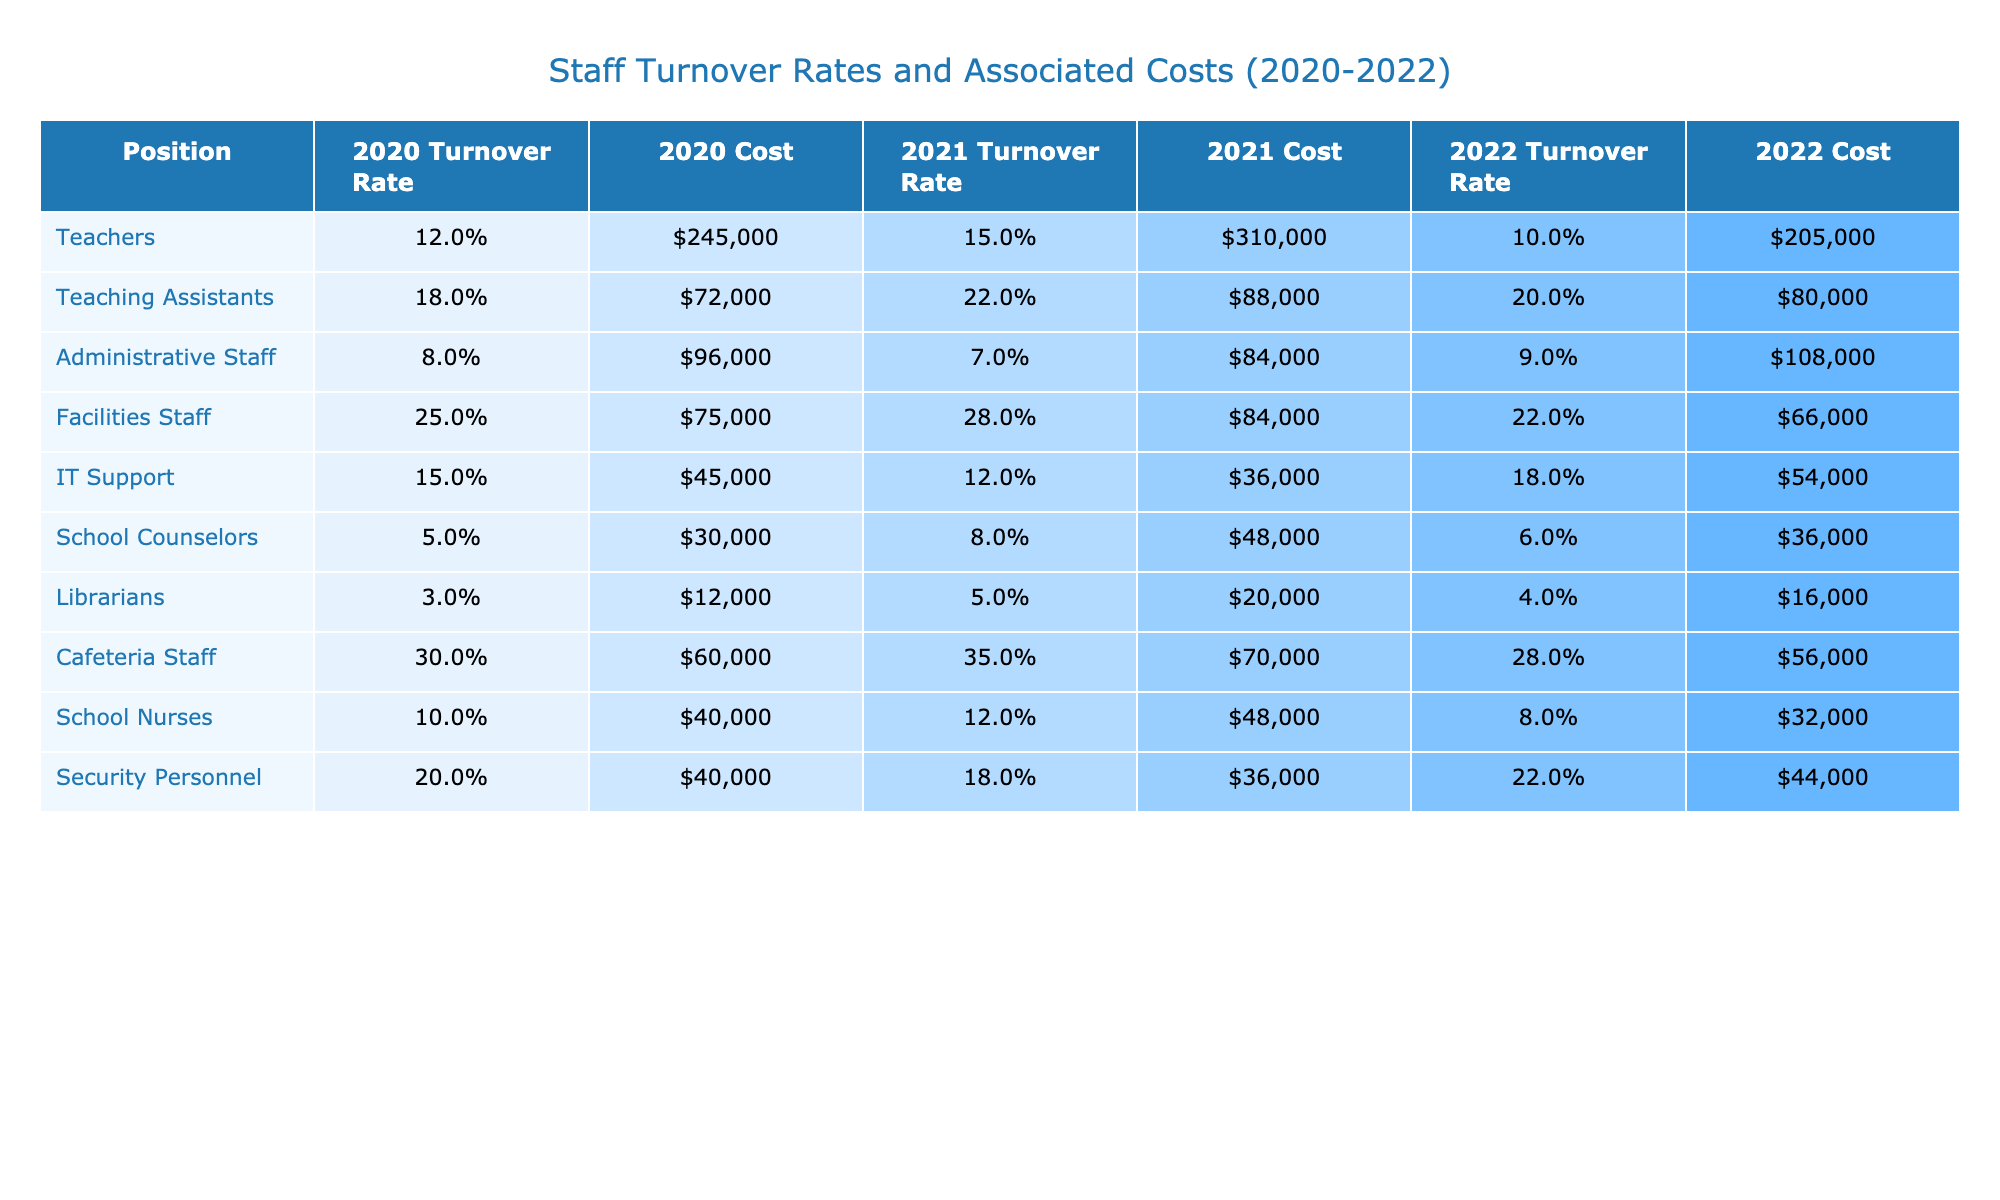What was the turnover rate for Teachers in 2021? The table shows the turnover rate for Teachers in 2021 is listed under the column for that year. Upon checking, it indicates that the rate is 15%.
Answer: 15% Which position had the highest turnover rate in 2020? By examining the turnover rates for each position in 2020, it is clear that Cafeteria Staff has the highest turnover rate at 30%.
Answer: Cafeteria Staff What was the total cost associated with turnover for Administrative Staff across the three years? The costs for Administrative Staff in each year are $96,000, $84,000, and $108,000. Adding these amounts gives a total of $288,000.
Answer: $288,000 Did the turnover cost for School Counselors increase from 2020 to 2021? The cost for School Counselors in 2020 was $30,000 and increased to $48,000 in 2021. Thus, the cost did increase.
Answer: Yes What is the average turnover rate for Teaching Assistants over the 3 years? The turnover rates for Teaching Assistants are 18%, 22%, and 20%. To find the average, sum these percentages (18 + 22 + 20 = 60) and divide by 3, resulting in an average of 20%.
Answer: 20% Did the turnover rate for Facilities Staff improve in 2022 compared to 2021? The turnover rate for Facilities Staff in 2021 was 28%, and it decreased to 22% in 2022, indicating an improvement.
Answer: Yes What is the cost difference associated with turnover between Teachers in 2020 and 2022? The cost for Teachers in 2020 was $245,000, and in 2022 it was $205,000. Subtracting these gives a difference of $40,000.
Answer: $40,000 Which position group had the most significant reduction in turnover cost from 2021 to 2022? Examining the turnover costs in 2021 and 2022 shows that Cafeteria Staff had costs of $70,000 in 2021 and decreased to $56,000 in 2022, a reduction of $14,000, which is the most significant drop.
Answer: Cafeteria Staff What was the highest turnover cost for IT Support during the three years? The turnover costs for IT Support were $45,000, $36,000, and $54,000 for the respective years. The highest cost is $54,000 in 2022.
Answer: $54,000 Which position showed the least turnover cost overall across the three years? Analyzing the costs for each position shows that Librarians have the lowest total costs of $12,000 + $20,000 + $16,000 = $48,000.
Answer: Librarians 